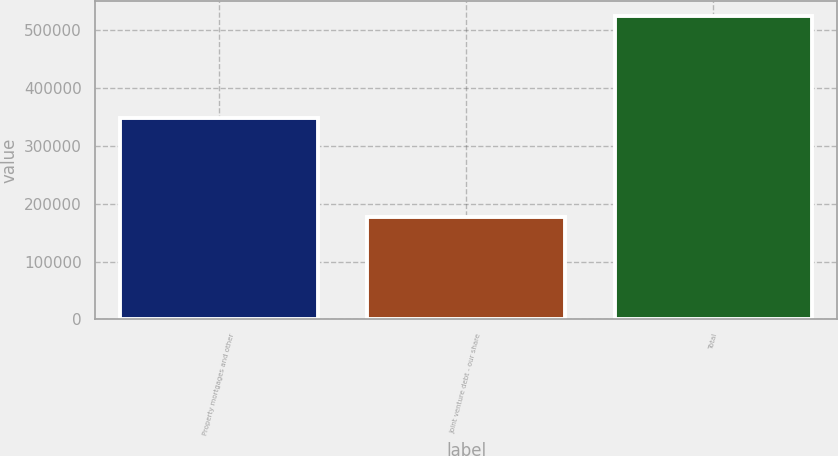Convert chart. <chart><loc_0><loc_0><loc_500><loc_500><bar_chart><fcel>Property mortgages and other<fcel>Joint venture debt - our share<fcel>Total<nl><fcel>348505<fcel>176511<fcel>525016<nl></chart> 